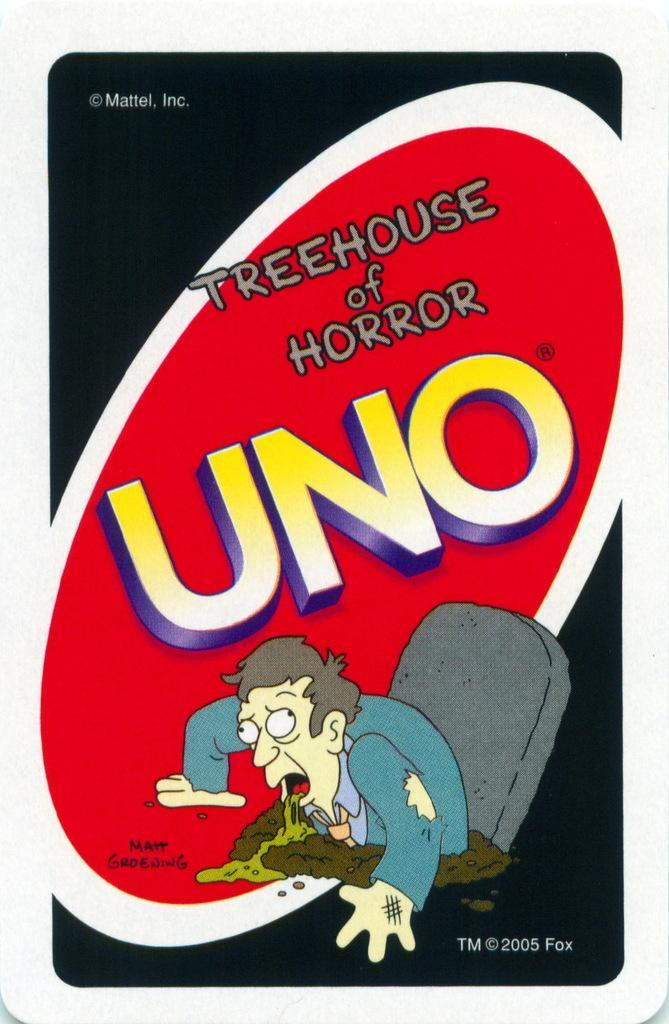Could you give a brief overview of what you see in this image? This is a poster having an animated image of a person who is vomiting. Beside this person, there is a chair. On the bottom right, there is a watermark. On the top left, there is a watermark. In the middle of this image, there are texts on a red color surface. Around this red color surface, there is a white color border in an ellipse shape. And the background of this poster is dark in color. 